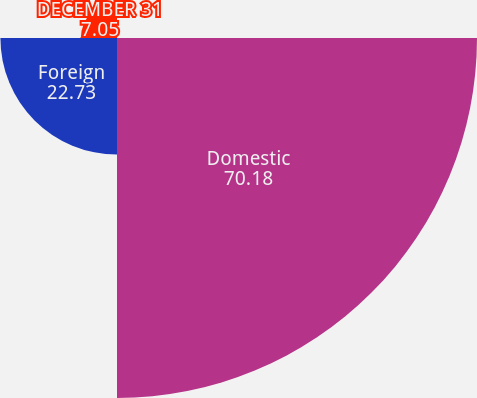Convert chart to OTSL. <chart><loc_0><loc_0><loc_500><loc_500><pie_chart><fcel>YEARS ENDED DECEMBER 31<fcel>Domestic<fcel>Foreign<fcel>DECEMBER 31<nl><fcel>0.04%<fcel>70.18%<fcel>22.73%<fcel>7.05%<nl></chart> 